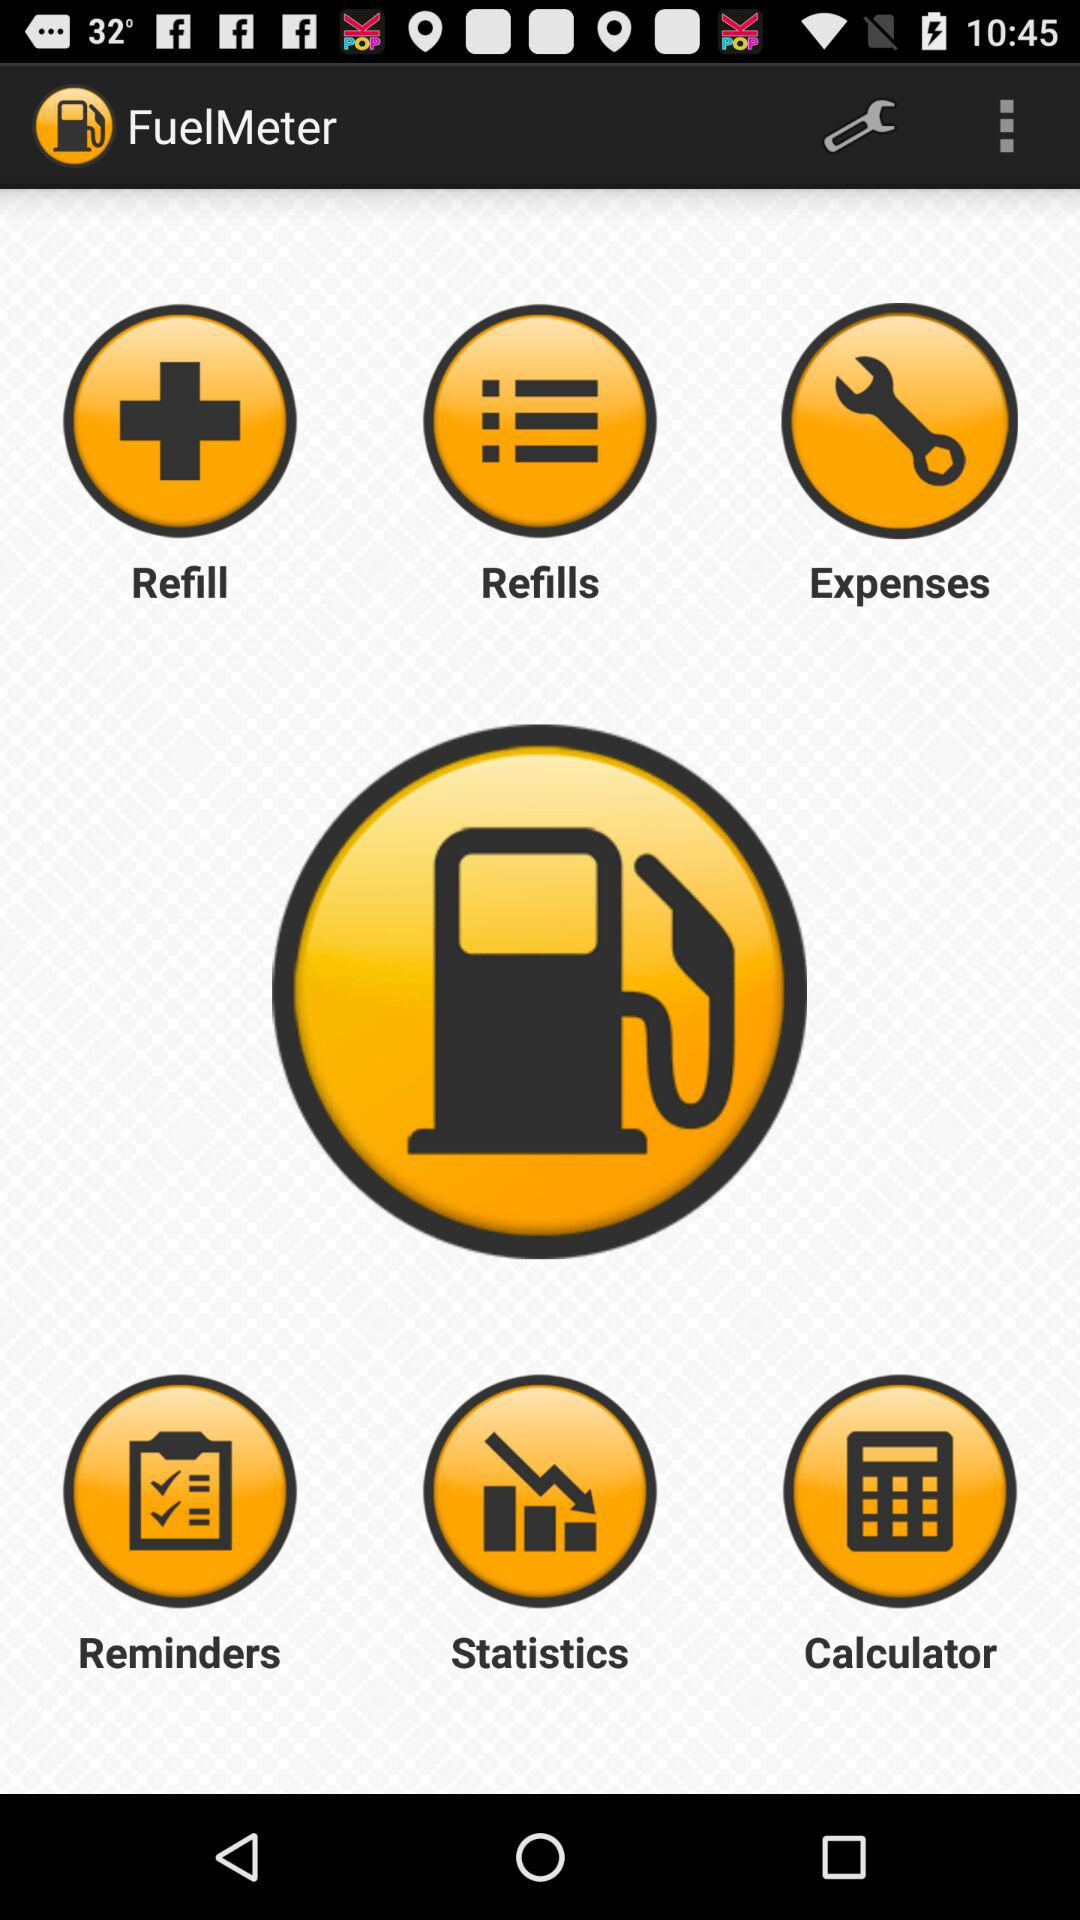What is the name of the application? The name of the application is "FuelMeter". 